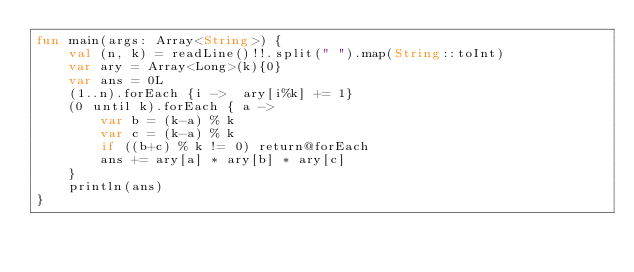<code> <loc_0><loc_0><loc_500><loc_500><_Kotlin_>fun main(args: Array<String>) {
    val (n, k) = readLine()!!.split(" ").map(String::toInt)
    var ary = Array<Long>(k){0}
    var ans = 0L
    (1..n).forEach {i ->  ary[i%k] += 1}
    (0 until k).forEach { a ->
        var b = (k-a) % k
        var c = (k-a) % k
        if ((b+c) % k != 0) return@forEach
        ans += ary[a] * ary[b] * ary[c]
    }
    println(ans)
}</code> 